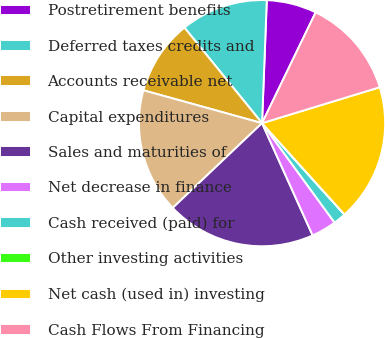Convert chart. <chart><loc_0><loc_0><loc_500><loc_500><pie_chart><fcel>Postretirement benefits<fcel>Deferred taxes credits and<fcel>Accounts receivable net<fcel>Capital expenditures<fcel>Sales and maturities of<fcel>Net decrease in finance<fcel>Cash received (paid) for<fcel>Other investing activities<fcel>Net cash (used in) investing<fcel>Cash Flows From Financing<nl><fcel>6.56%<fcel>11.47%<fcel>9.84%<fcel>16.38%<fcel>19.66%<fcel>3.29%<fcel>1.65%<fcel>0.01%<fcel>18.02%<fcel>13.11%<nl></chart> 